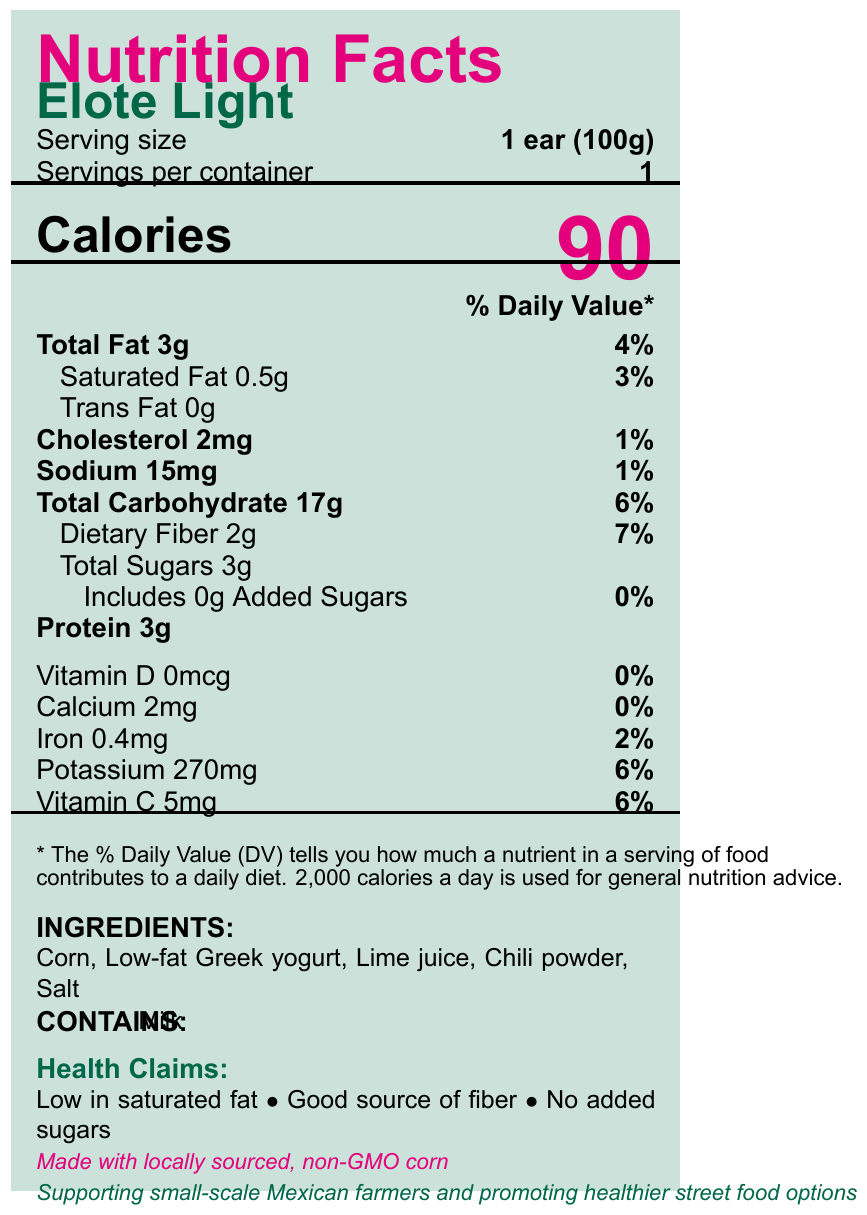what is the product name? The product name is displayed prominently at the top of the document.
Answer: Elote Light what is the serving size? The serving size is listed under the product name and labeled as "Serving size."
Answer: 1 ear (100g) how many calories are in one serving? The number of calories is highlighted in large text under the "Calories" section.
Answer: 90 how much total fat is in the product, and what is its % Daily Value? The total fat amount and % Daily Value are listed in the "Total Fat" section.
Answer: 3g, 4% how many grams of dietary fiber does the product contain? The amount of dietary fiber is listed under the "Total Carbohydrate" section.
Answer: 2g what ingredients are used in this product? The ingredients are listed towards the bottom under the "Ingredients" section.
Answer: Corn, Low-fat Greek yogurt, Lime juice, Chili powder, Salt what health benefits are claimed for this product? (Choose all that apply) A. Low in sugar B. High in protein C. Good source of fiber D. Low in saturated fat The health claims listed are "Good source of fiber" and "Low in saturated fat."
Answer: C, D which nutrient has the highest % Daily Value? A. Total Fat B. Sodium C. Dietary Fiber D. Iron The % Daily Value for Dietary Fiber is 7%, which is higher than the others listed.
Answer: C. Dietary Fiber is there any Vitamin D in this product? The document indicates 0mcg of Vitamin D with a 0% Daily Value.
Answer: No does this product contain any allergens? The document mentions that the product contains milk under the "CONTAINS:" section.
Answer: Yes what is the main idea of this document? The document comprehensively outlines the nutritional information, ingredients, and health claims of Elote Light, along with notes on sustainability and political context.
Answer: The document provides the Nutrition Facts Label for Elote Light, a low-calorie Mexican street food, highlighting its nutritional content, ingredients, health claims, and sustainability notes. what is the exact amount of iron in the product? The amount of iron is listed under the "Iron" section of the nutrient table.
Answer: 0.4mg who is the producer of this product? The document does not provide information about the producer of Elote Light.
Answer: Cannot be determined 